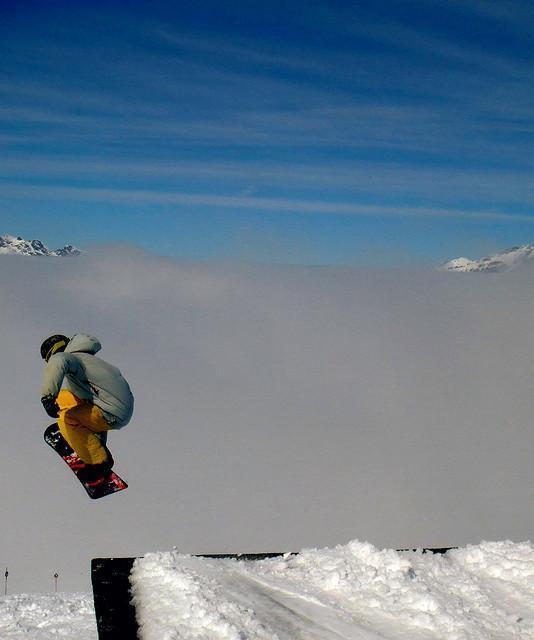How many people are there?
Give a very brief answer. 1. 